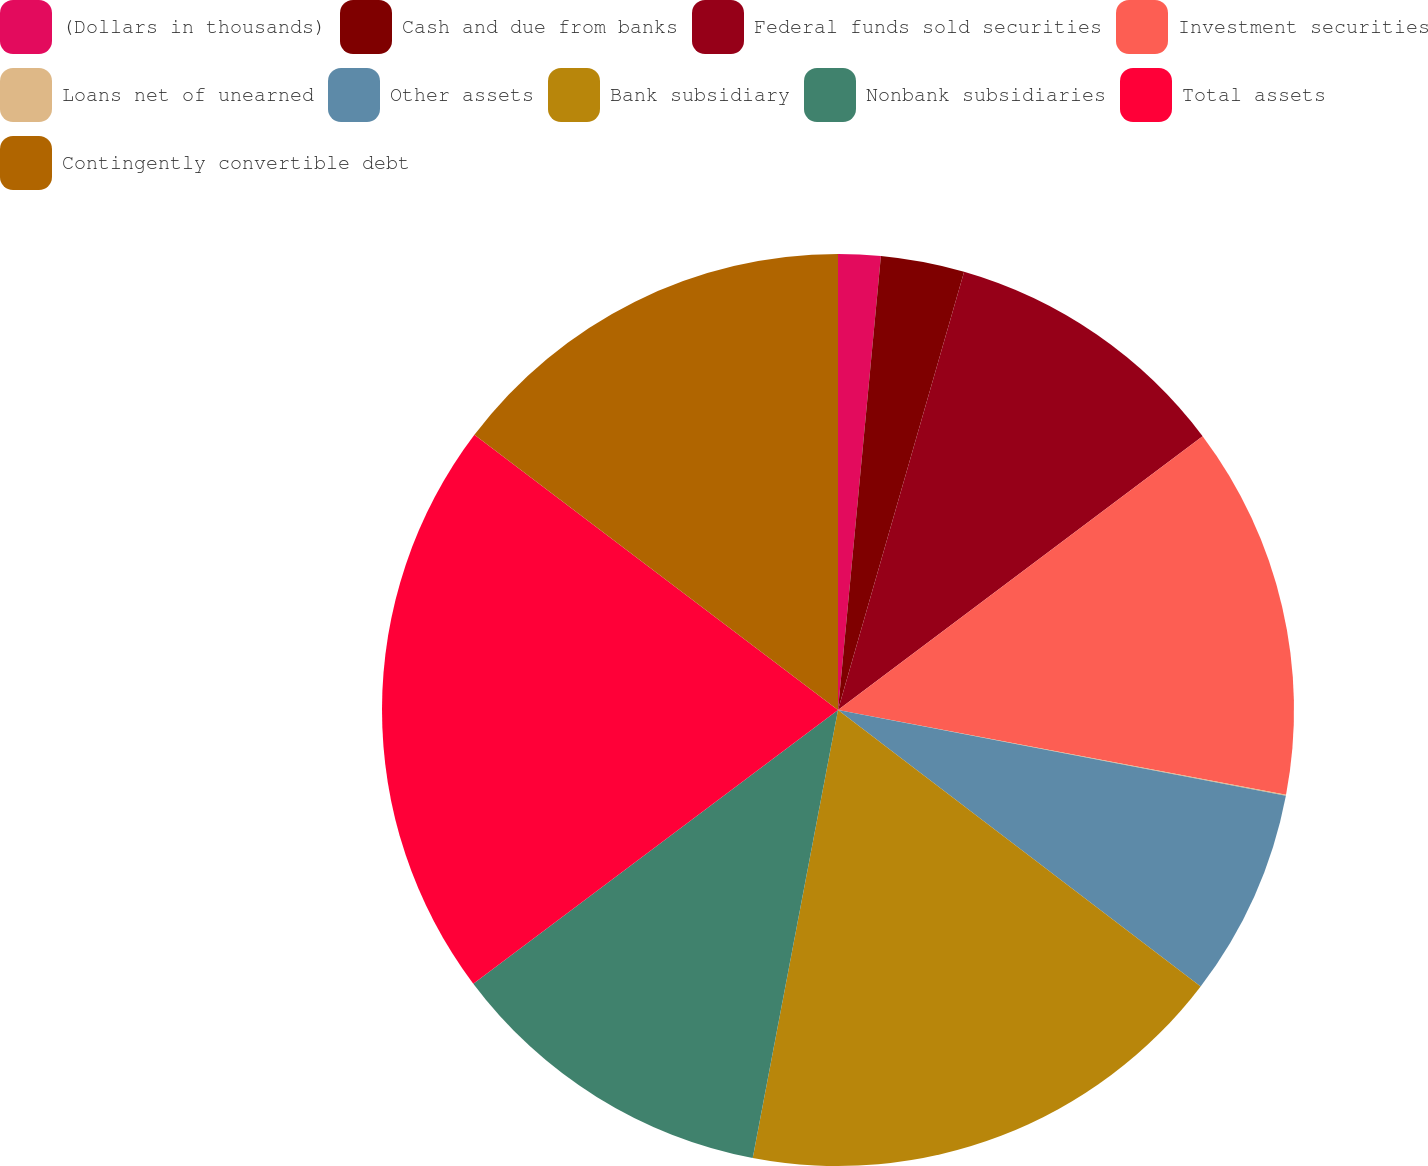Convert chart to OTSL. <chart><loc_0><loc_0><loc_500><loc_500><pie_chart><fcel>(Dollars in thousands)<fcel>Cash and due from banks<fcel>Federal funds sold securities<fcel>Investment securities<fcel>Loans net of unearned<fcel>Other assets<fcel>Bank subsidiary<fcel>Nonbank subsidiaries<fcel>Total assets<fcel>Contingently convertible debt<nl><fcel>1.5%<fcel>2.96%<fcel>10.29%<fcel>13.23%<fcel>0.03%<fcel>7.36%<fcel>17.63%<fcel>11.76%<fcel>20.56%<fcel>14.69%<nl></chart> 